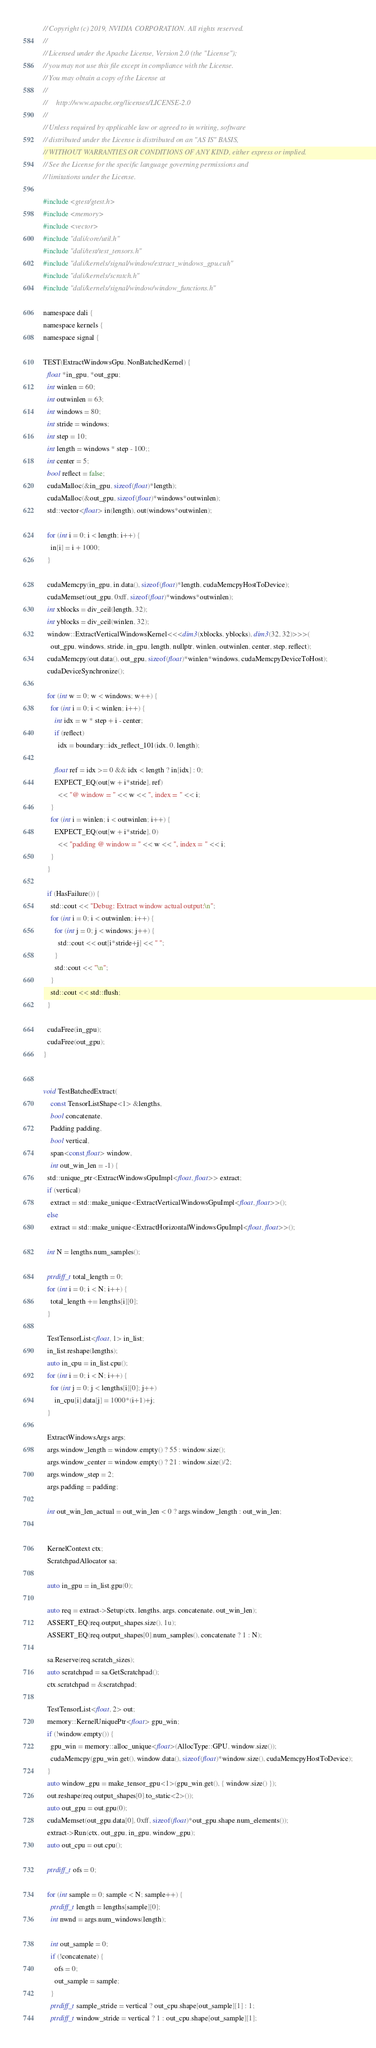<code> <loc_0><loc_0><loc_500><loc_500><_Cuda_>// Copyright (c) 2019, NVIDIA CORPORATION. All rights reserved.
//
// Licensed under the Apache License, Version 2.0 (the "License");
// you may not use this file except in compliance with the License.
// You may obtain a copy of the License at
//
//     http://www.apache.org/licenses/LICENSE-2.0
//
// Unless required by applicable law or agreed to in writing, software
// distributed under the License is distributed on an "AS IS" BASIS,
// WITHOUT WARRANTIES OR CONDITIONS OF ANY KIND, either express or implied.
// See the License for the specific language governing permissions and
// limitations under the License.

#include <gtest/gtest.h>
#include <memory>
#include <vector>
#include "dali/core/util.h"
#include "dali/test/test_tensors.h"
#include "dali/kernels/signal/window/extract_windows_gpu.cuh"
#include "dali/kernels/scratch.h"
#include "dali/kernels/signal/window/window_functions.h"

namespace dali {
namespace kernels {
namespace signal {

TEST(ExtractWindowsGpu, NonBatchedKernel) {
  float *in_gpu, *out_gpu;
  int winlen = 60;
  int outwinlen = 63;
  int windows = 80;
  int stride = windows;
  int step = 10;
  int length = windows * step - 100;;
  int center = 5;
  bool reflect = false;
  cudaMalloc(&in_gpu, sizeof(float)*length);
  cudaMalloc(&out_gpu, sizeof(float)*windows*outwinlen);
  std::vector<float> in(length), out(windows*outwinlen);

  for (int i = 0; i < length; i++) {
    in[i] = i + 1000;
  }

  cudaMemcpy(in_gpu, in.data(), sizeof(float)*length, cudaMemcpyHostToDevice);
  cudaMemset(out_gpu, 0xff, sizeof(float)*windows*outwinlen);
  int xblocks = div_ceil(length, 32);
  int yblocks = div_ceil(winlen, 32);
  window::ExtractVerticalWindowsKernel<<<dim3(xblocks, yblocks), dim3(32, 32)>>>(
    out_gpu, windows, stride, in_gpu, length, nullptr, winlen, outwinlen, center, step, reflect);
  cudaMemcpy(out.data(), out_gpu, sizeof(float)*winlen*windows, cudaMemcpyDeviceToHost);
  cudaDeviceSynchronize();

  for (int w = 0; w < windows; w++) {
    for (int i = 0; i < winlen; i++) {
      int idx = w * step + i - center;
      if (reflect)
        idx = boundary::idx_reflect_101(idx, 0, length);

      float ref = idx >= 0 && idx < length ? in[idx] : 0;
      EXPECT_EQ(out[w + i*stride], ref)
        << "@ window = " << w << ", index = " << i;
    }
    for (int i = winlen; i < outwinlen; i++) {
      EXPECT_EQ(out[w + i*stride], 0)
        << "padding @ window = " << w << ", index = " << i;
    }
  }

  if (HasFailure()) {
    std::cout << "Debug: Extract window actual output:\n";
    for (int i = 0; i < outwinlen; i++) {
      for (int j = 0; j < windows; j++) {
        std::cout << out[i*stride+j] << " ";
      }
      std::cout << "\n";
    }
    std::cout << std::flush;
  }

  cudaFree(in_gpu);
  cudaFree(out_gpu);
}


void TestBatchedExtract(
    const TensorListShape<1> &lengths,
    bool concatenate,
    Padding padding,
    bool vertical,
    span<const float> window,
    int out_win_len = -1) {
  std::unique_ptr<ExtractWindowsGpuImpl<float, float>> extract;
  if (vertical)
    extract = std::make_unique<ExtractVerticalWindowsGpuImpl<float, float>>();
  else
    extract = std::make_unique<ExtractHorizontalWindowsGpuImpl<float, float>>();

  int N = lengths.num_samples();

  ptrdiff_t total_length = 0;
  for (int i = 0; i < N; i++) {
    total_length += lengths[i][0];
  }

  TestTensorList<float, 1> in_list;
  in_list.reshape(lengths);
  auto in_cpu = in_list.cpu();
  for (int i = 0; i < N; i++) {
    for (int j = 0; j < lengths[i][0]; j++)
      in_cpu[i].data[j] = 1000*(i+1)+j;
  }

  ExtractWindowsArgs args;
  args.window_length = window.empty() ? 55 : window.size();
  args.window_center = window.empty() ? 21 : window.size()/2;
  args.window_step = 2;
  args.padding = padding;

  int out_win_len_actual = out_win_len < 0 ? args.window_length : out_win_len;


  KernelContext ctx;
  ScratchpadAllocator sa;

  auto in_gpu = in_list.gpu(0);

  auto req = extract->Setup(ctx, lengths, args, concatenate, out_win_len);
  ASSERT_EQ(req.output_shapes.size(), 1u);
  ASSERT_EQ(req.output_shapes[0].num_samples(), concatenate ? 1 : N);

  sa.Reserve(req.scratch_sizes);
  auto scratchpad = sa.GetScratchpad();
  ctx.scratchpad = &scratchpad;

  TestTensorList<float, 2> out;
  memory::KernelUniquePtr<float> gpu_win;
  if (!window.empty()) {
    gpu_win = memory::alloc_unique<float>(AllocType::GPU, window.size());
    cudaMemcpy(gpu_win.get(), window.data(), sizeof(float)*window.size(), cudaMemcpyHostToDevice);
  }
  auto window_gpu = make_tensor_gpu<1>(gpu_win.get(), { window.size() });
  out.reshape(req.output_shapes[0].to_static<2>());
  auto out_gpu = out.gpu(0);
  cudaMemset(out_gpu.data[0], 0xff, sizeof(float)*out_gpu.shape.num_elements());
  extract->Run(ctx, out_gpu, in_gpu, window_gpu);
  auto out_cpu = out.cpu();

  ptrdiff_t ofs = 0;

  for (int sample = 0; sample < N; sample++) {
    ptrdiff_t length = lengths[sample][0];
    int nwnd = args.num_windows(length);

    int out_sample = 0;
    if (!concatenate) {
      ofs = 0;
      out_sample = sample;
    }
    ptrdiff_t sample_stride = vertical ? out_cpu.shape[out_sample][1] : 1;
    ptrdiff_t window_stride = vertical ? 1 : out_cpu.shape[out_sample][1];
</code> 